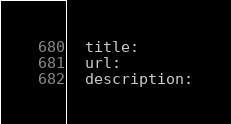<code> <loc_0><loc_0><loc_500><loc_500><_YAML_>  title:
  url:
  description:

</code> 